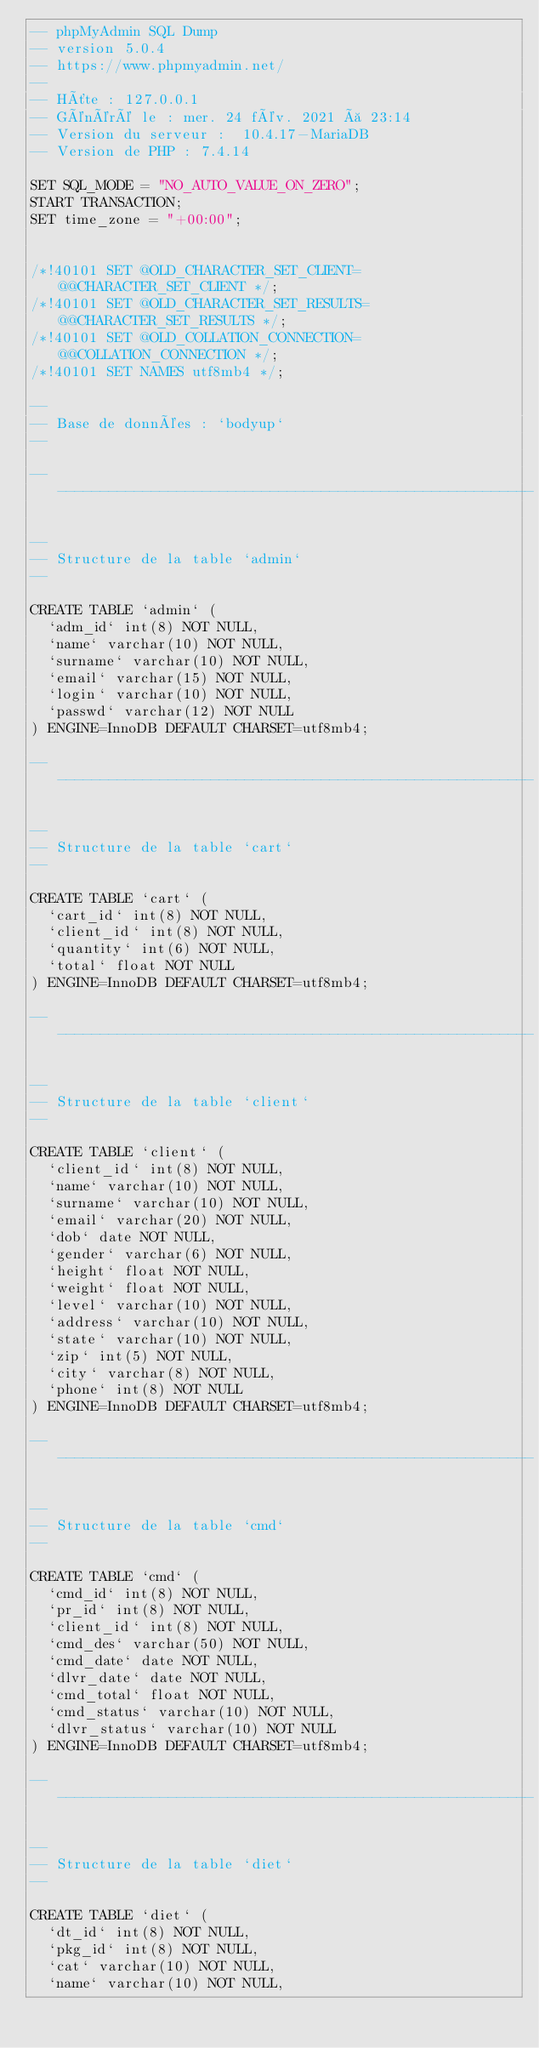<code> <loc_0><loc_0><loc_500><loc_500><_SQL_>-- phpMyAdmin SQL Dump
-- version 5.0.4
-- https://www.phpmyadmin.net/
--
-- Hôte : 127.0.0.1
-- Généré le : mer. 24 fév. 2021 à 23:14
-- Version du serveur :  10.4.17-MariaDB
-- Version de PHP : 7.4.14

SET SQL_MODE = "NO_AUTO_VALUE_ON_ZERO";
START TRANSACTION;
SET time_zone = "+00:00";


/*!40101 SET @OLD_CHARACTER_SET_CLIENT=@@CHARACTER_SET_CLIENT */;
/*!40101 SET @OLD_CHARACTER_SET_RESULTS=@@CHARACTER_SET_RESULTS */;
/*!40101 SET @OLD_COLLATION_CONNECTION=@@COLLATION_CONNECTION */;
/*!40101 SET NAMES utf8mb4 */;

--
-- Base de données : `bodyup`
--

-- --------------------------------------------------------

--
-- Structure de la table `admin`
--

CREATE TABLE `admin` (
  `adm_id` int(8) NOT NULL,
  `name` varchar(10) NOT NULL,
  `surname` varchar(10) NOT NULL,
  `email` varchar(15) NOT NULL,
  `login` varchar(10) NOT NULL,
  `passwd` varchar(12) NOT NULL
) ENGINE=InnoDB DEFAULT CHARSET=utf8mb4;

-- --------------------------------------------------------

--
-- Structure de la table `cart`
--

CREATE TABLE `cart` (
  `cart_id` int(8) NOT NULL,
  `client_id` int(8) NOT NULL,
  `quantity` int(6) NOT NULL,
  `total` float NOT NULL
) ENGINE=InnoDB DEFAULT CHARSET=utf8mb4;

-- --------------------------------------------------------

--
-- Structure de la table `client`
--

CREATE TABLE `client` (
  `client_id` int(8) NOT NULL,
  `name` varchar(10) NOT NULL,
  `surname` varchar(10) NOT NULL,
  `email` varchar(20) NOT NULL,
  `dob` date NOT NULL,
  `gender` varchar(6) NOT NULL,
  `height` float NOT NULL,
  `weight` float NOT NULL,
  `level` varchar(10) NOT NULL,
  `address` varchar(10) NOT NULL,
  `state` varchar(10) NOT NULL,
  `zip` int(5) NOT NULL,
  `city` varchar(8) NOT NULL,
  `phone` int(8) NOT NULL
) ENGINE=InnoDB DEFAULT CHARSET=utf8mb4;

-- --------------------------------------------------------

--
-- Structure de la table `cmd`
--

CREATE TABLE `cmd` (
  `cmd_id` int(8) NOT NULL,
  `pr_id` int(8) NOT NULL,
  `client_id` int(8) NOT NULL,
  `cmd_des` varchar(50) NOT NULL,
  `cmd_date` date NOT NULL,
  `dlvr_date` date NOT NULL,
  `cmd_total` float NOT NULL,
  `cmd_status` varchar(10) NOT NULL,
  `dlvr_status` varchar(10) NOT NULL
) ENGINE=InnoDB DEFAULT CHARSET=utf8mb4;

-- --------------------------------------------------------

--
-- Structure de la table `diet`
--

CREATE TABLE `diet` (
  `dt_id` int(8) NOT NULL,
  `pkg_id` int(8) NOT NULL,
  `cat` varchar(10) NOT NULL,
  `name` varchar(10) NOT NULL,</code> 